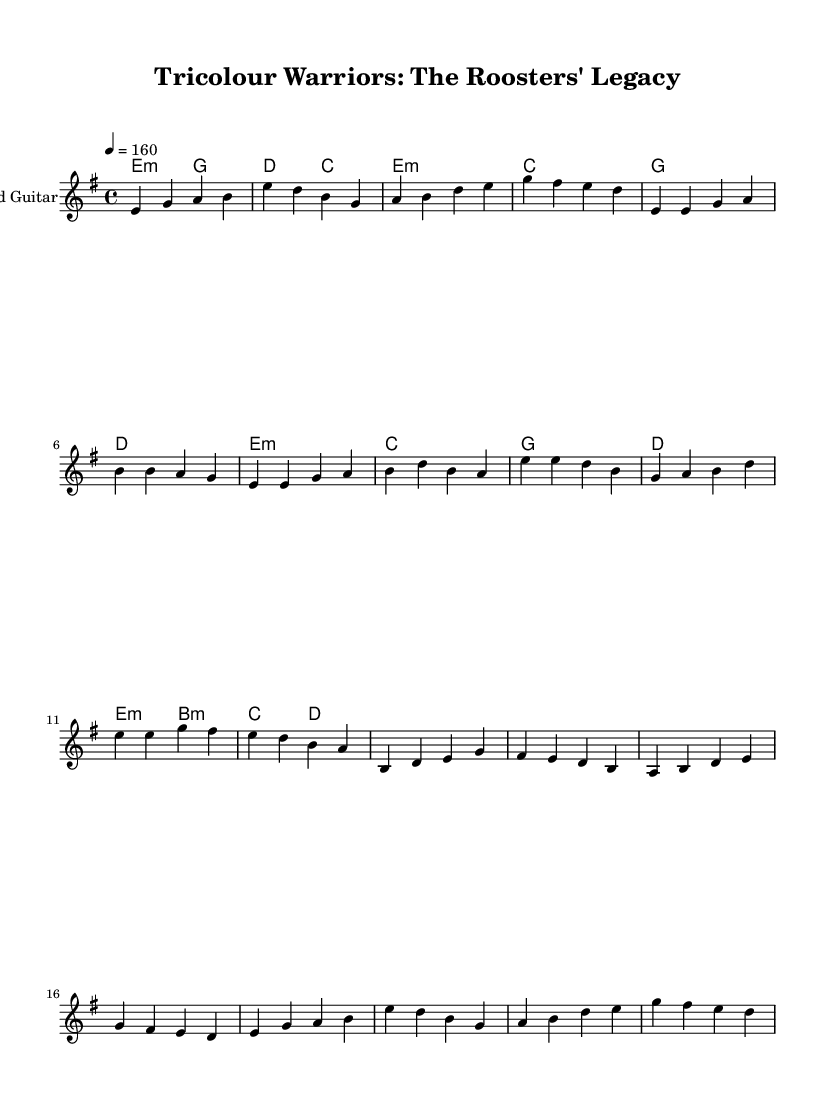What is the key signature of this music? The key signature indicated at the beginning of the score is E minor, which has one sharp (F#).
Answer: E minor What is the time signature of this music? The time signature shown in the sheet music is 4/4, which means there are four beats in each measure and a quarter note gets one beat.
Answer: 4/4 What is the tempo marking of this music? The tempo marking indicates a speed of 160 beats per minute, which suggests a fast-paced musical piece.
Answer: 160 How many measures are present in the melody section? The melody section includes several distinct parts; counting the repeated sections and variances, there are a total of 14 measures in the melody.
Answer: 14 What type of chords are primarily used in the harmonies? The harmonies mostly consist of minor chords, which are characterized by a root, minor third, and perfect fifth.
Answer: Minor Which part of the music represents the chorus? The chorus is recognizable and represented by the specific melody that follows the prescribed verses in the structure, starting with the phrase "e e d b."
Answer: "e e d b." What style of music does this sheet reflect? The music reflects the power metal genre, characterized by its epic themes and energetic instrumentation, specifically recounting the history of the Sydney Roosters.
Answer: Power metal 